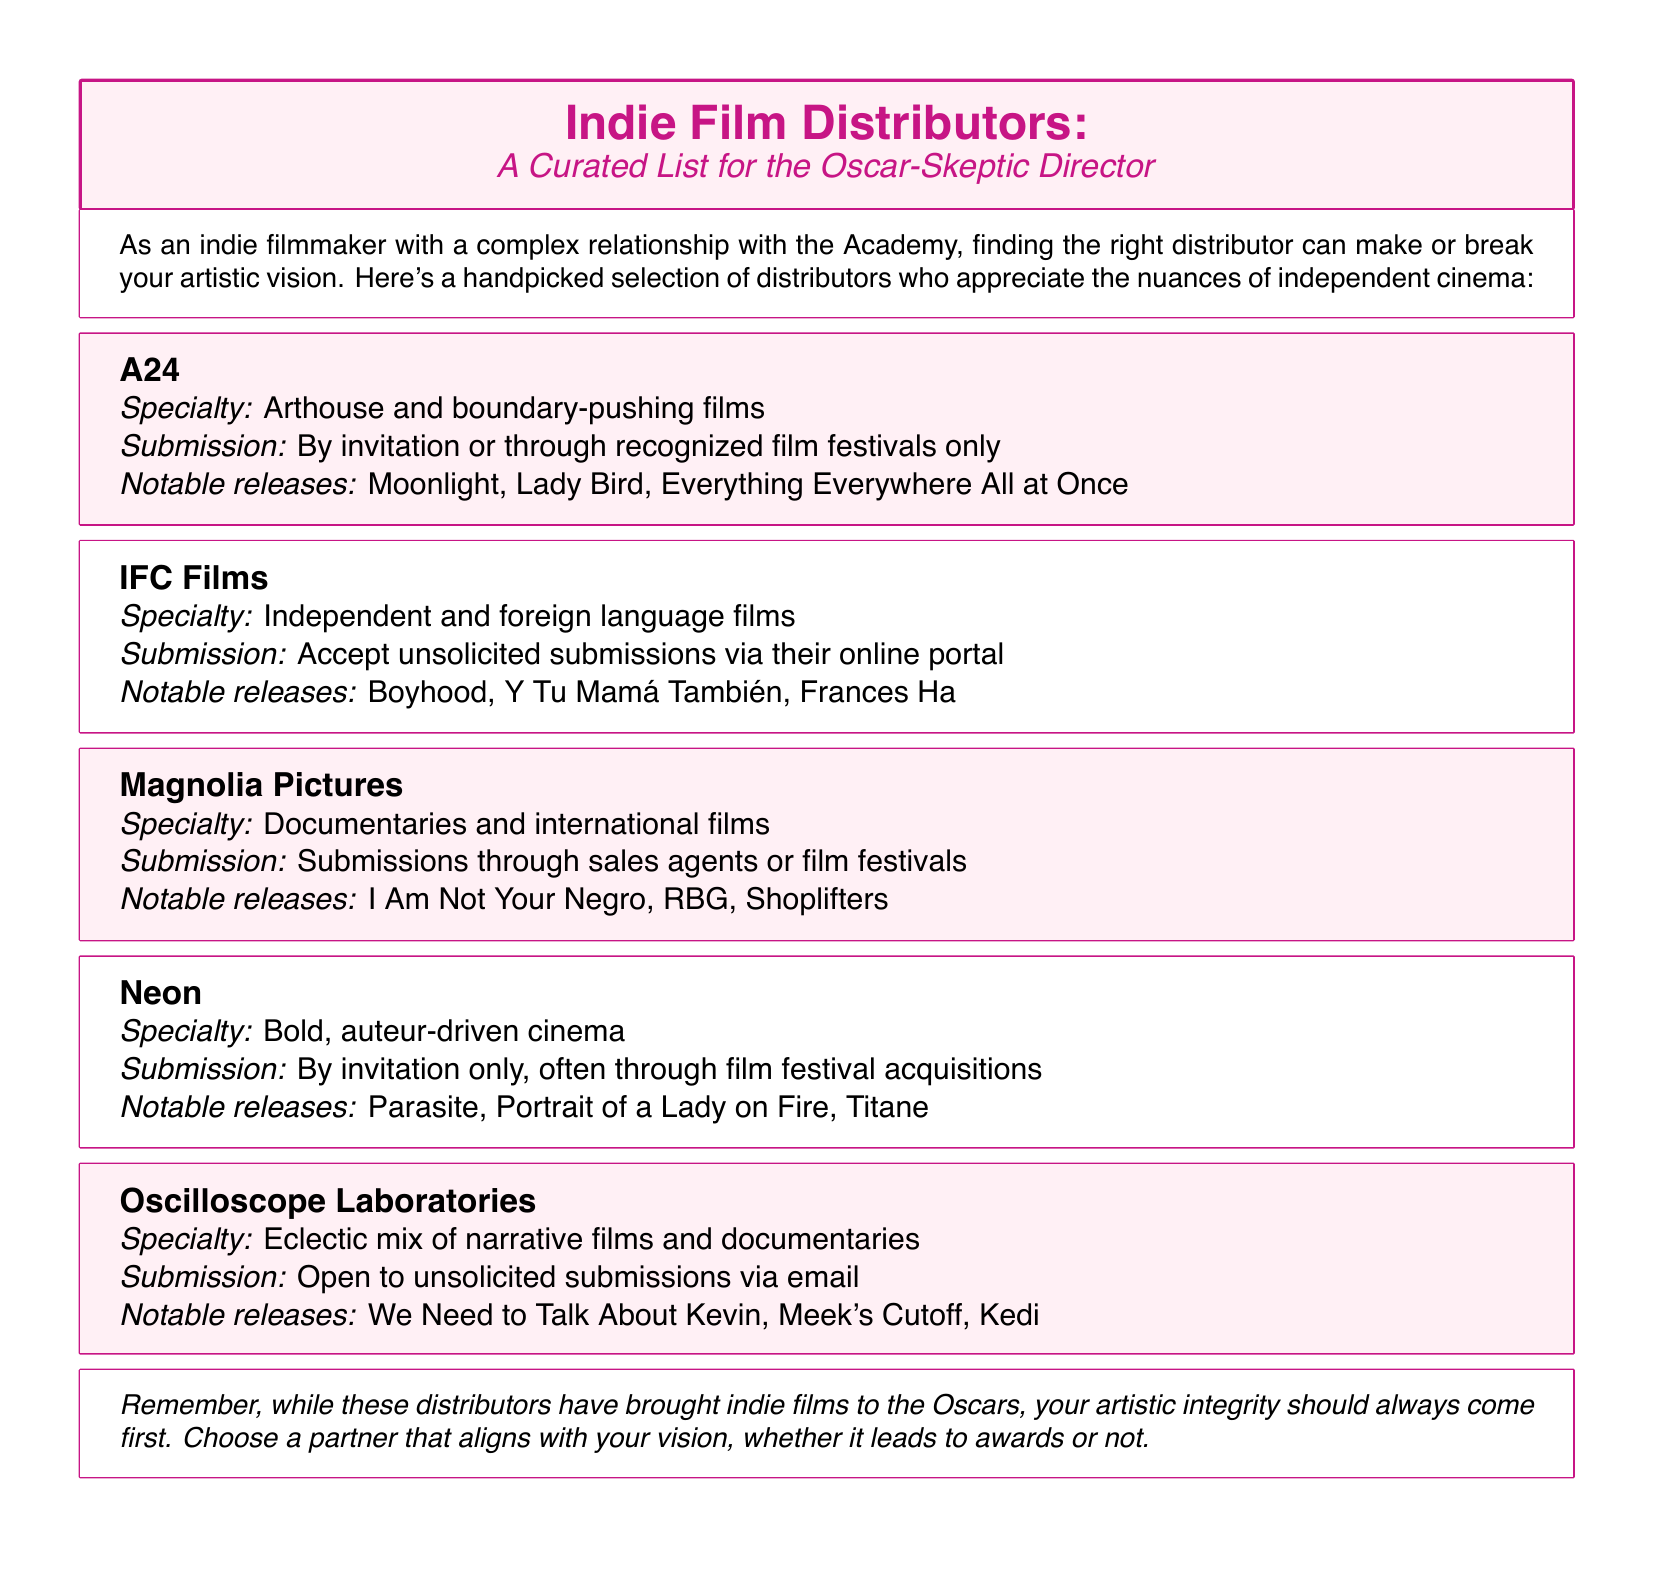What is A24's specialty? A24's specialty is described as "Arthouse and boundary-pushing films."
Answer: Arthouse and boundary-pushing films How can I submit to IFC Films? The document states that IFC Films accepts submissions via their online portal.
Answer: Online portal Name a notable release from Magnolia Pictures. The document lists several notable releases; one is "I Am Not Your Negro."
Answer: I Am Not Your Negro What type of films does Neon distribute? Neon specializes in "Bold, auteur-driven cinema."
Answer: Bold, auteur-driven cinema How does Oscilloscope Laboratories handle submissions? Oscilloscope Laboratories is open to unsolicited submissions via email, according to the document.
Answer: Via email Which distributor requires submissions by invitation only? The document indicates that Neon requires submissions by invitation only.
Answer: Neon What is the focus of Magnolia Pictures? The focus of Magnolia Pictures is on "Documentaries and international films."
Answer: Documentaries and international films Which distributor has notable films like "Moonlight" and "Everything Everywhere All at Once"? A24 is noted for distributing "Moonlight" and "Everything Everywhere All at Once."
Answer: A24 Is IFC Films open to unsolicited submissions? The document clarifies that IFC Films accepts unsolicited submissions.
Answer: Yes 